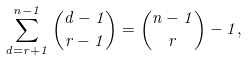Convert formula to latex. <formula><loc_0><loc_0><loc_500><loc_500>\sum _ { d = r + 1 } ^ { n - 1 } \binom { d - 1 } { r - 1 } = \binom { n - 1 } { r } - 1 ,</formula> 